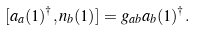Convert formula to latex. <formula><loc_0><loc_0><loc_500><loc_500>[ a _ { a } ( 1 ) ^ { \dagger } , n _ { b } ( 1 ) ] = g _ { { a } { b } } a _ { b } ( 1 ) ^ { \dagger } .</formula> 